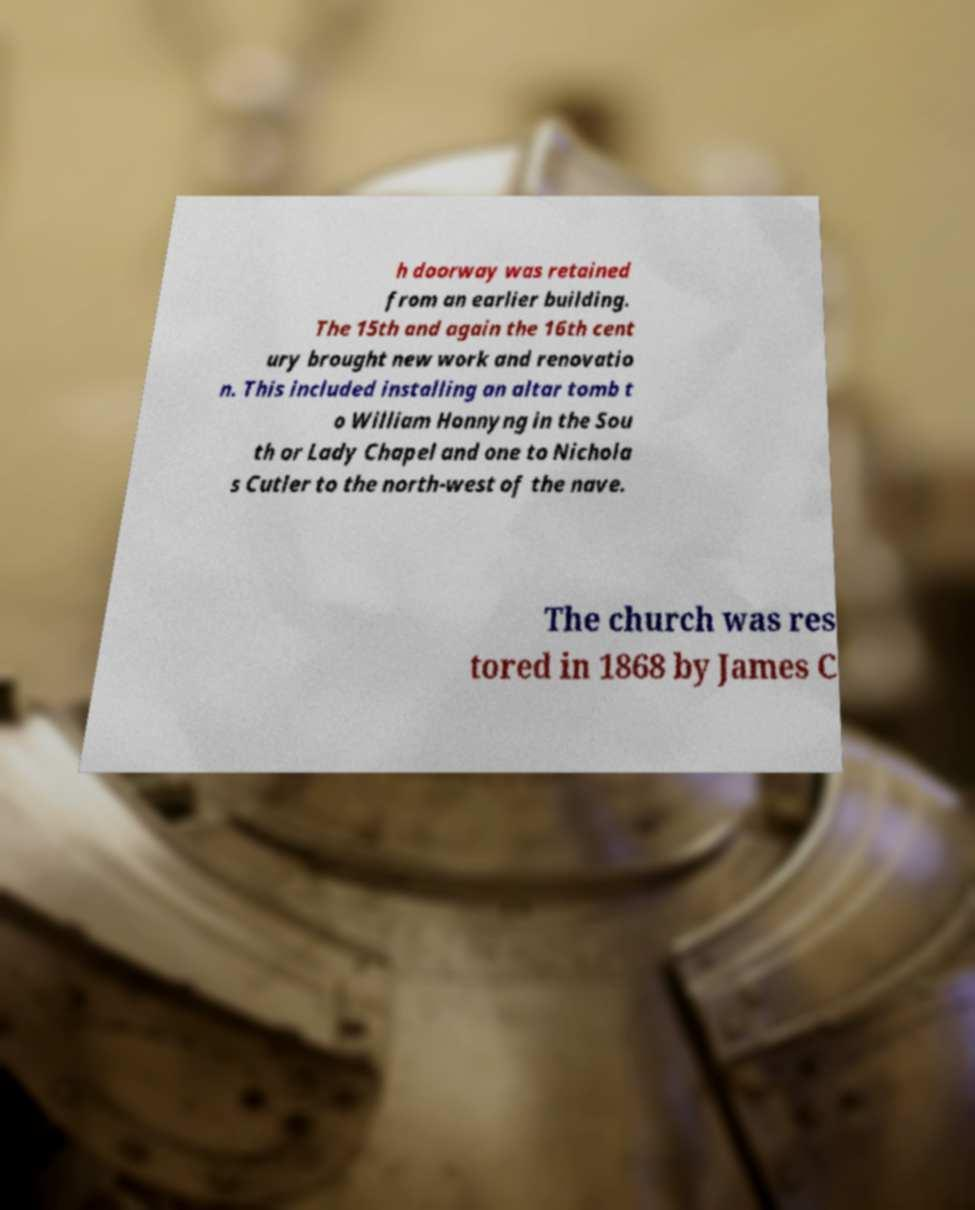What messages or text are displayed in this image? I need them in a readable, typed format. h doorway was retained from an earlier building. The 15th and again the 16th cent ury brought new work and renovatio n. This included installing an altar tomb t o William Honnyng in the Sou th or Lady Chapel and one to Nichola s Cutler to the north-west of the nave. The church was res tored in 1868 by James C 